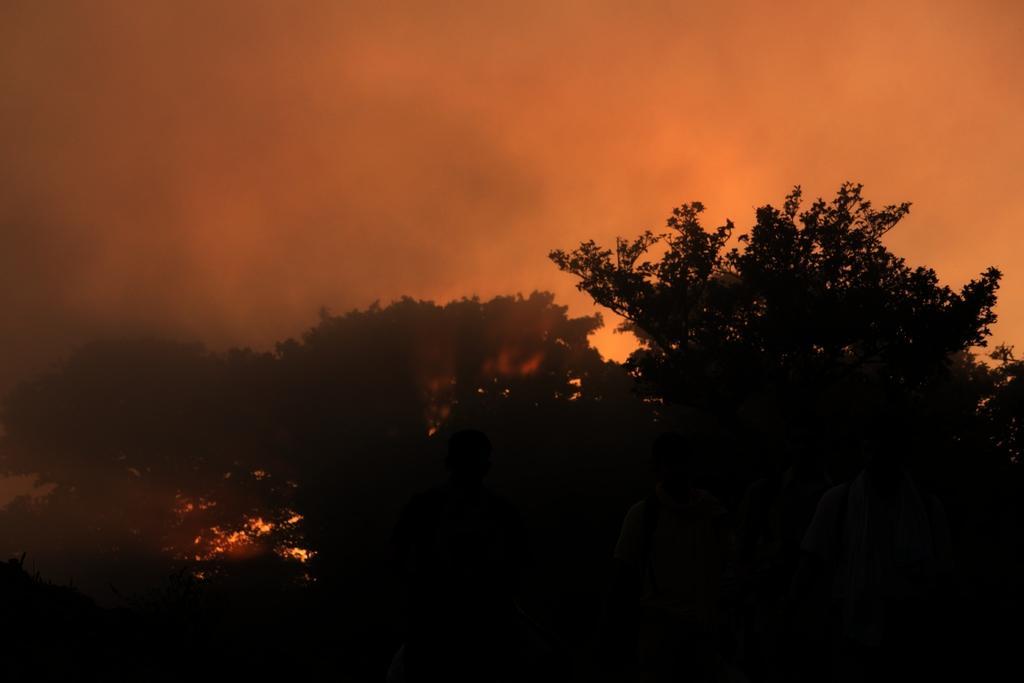Describe this image in one or two sentences. This picture is dark, in this picture we can see trees. In the background of the image we can see sky. 